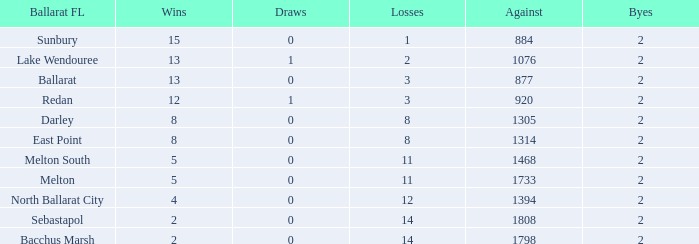What is the number of byes having 1076 against and less than 13 wins? None. 